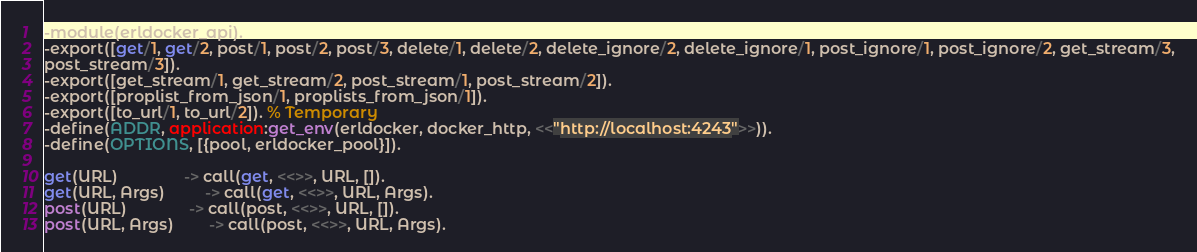<code> <loc_0><loc_0><loc_500><loc_500><_Erlang_>-module(erldocker_api).
-export([get/1, get/2, post/1, post/2, post/3, delete/1, delete/2, delete_ignore/2, delete_ignore/1, post_ignore/1, post_ignore/2, get_stream/3,
post_stream/3]).
-export([get_stream/1, get_stream/2, post_stream/1, post_stream/2]).
-export([proplist_from_json/1, proplists_from_json/1]).
-export([to_url/1, to_url/2]). % Temporary
-define(ADDR, application:get_env(erldocker, docker_http, <<"http://localhost:4243">>)).
-define(OPTIONS, [{pool, erldocker_pool}]).

get(URL)               -> call(get, <<>>, URL, []).
get(URL, Args)         -> call(get, <<>>, URL, Args).
post(URL)              -> call(post, <<>>, URL, []).
post(URL, Args)        -> call(post, <<>>, URL, Args).</code> 